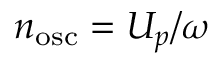<formula> <loc_0><loc_0><loc_500><loc_500>n _ { o s c } = U _ { p } / \omega</formula> 